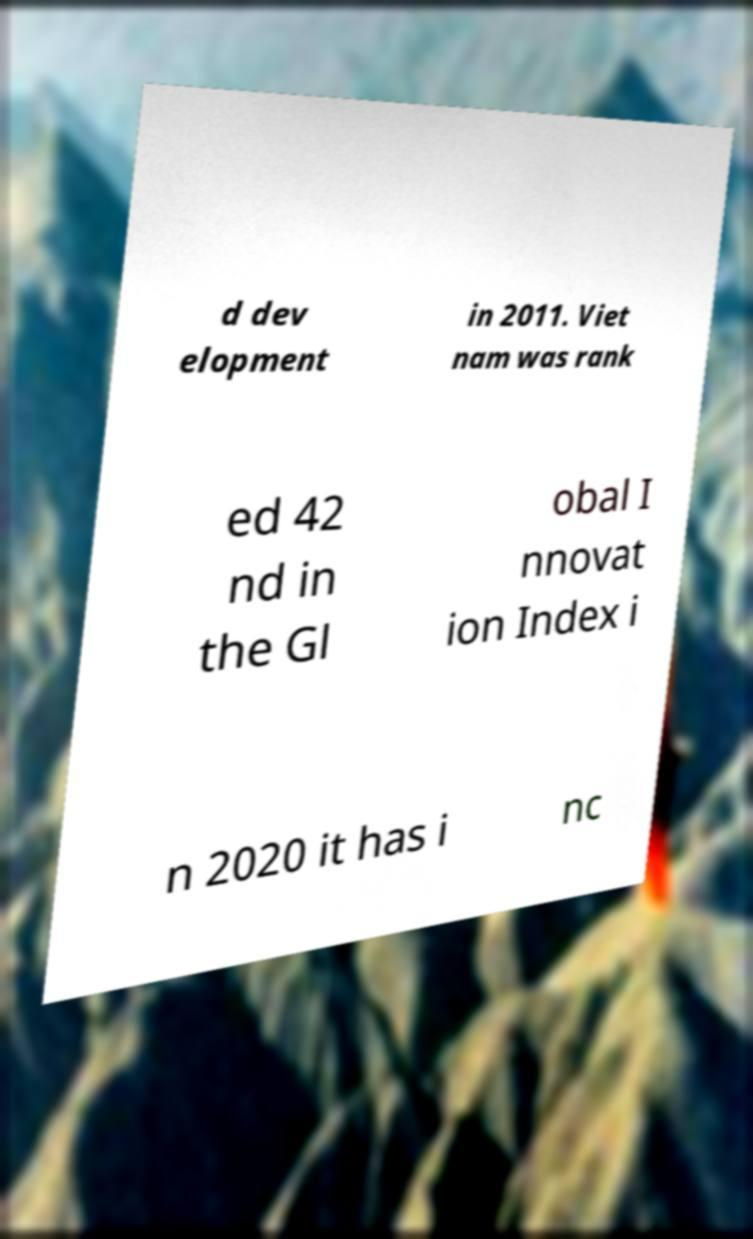For documentation purposes, I need the text within this image transcribed. Could you provide that? d dev elopment in 2011. Viet nam was rank ed 42 nd in the Gl obal I nnovat ion Index i n 2020 it has i nc 